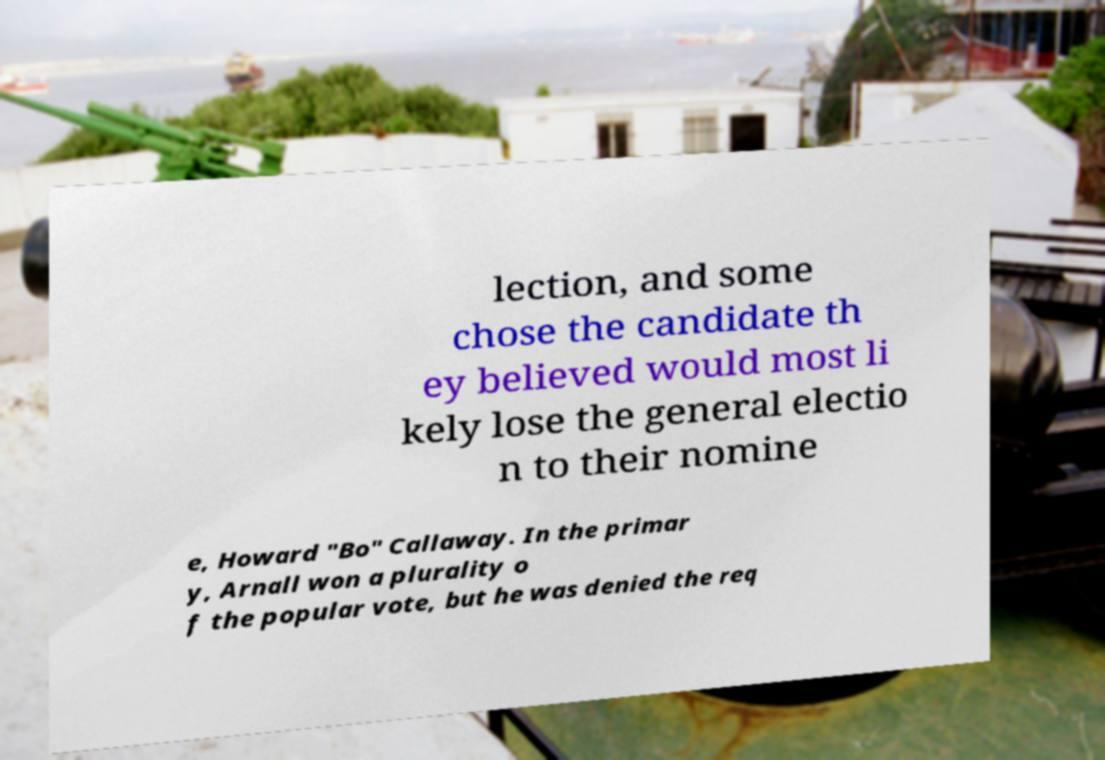There's text embedded in this image that I need extracted. Can you transcribe it verbatim? lection, and some chose the candidate th ey believed would most li kely lose the general electio n to their nomine e, Howard "Bo" Callaway. In the primar y, Arnall won a plurality o f the popular vote, but he was denied the req 